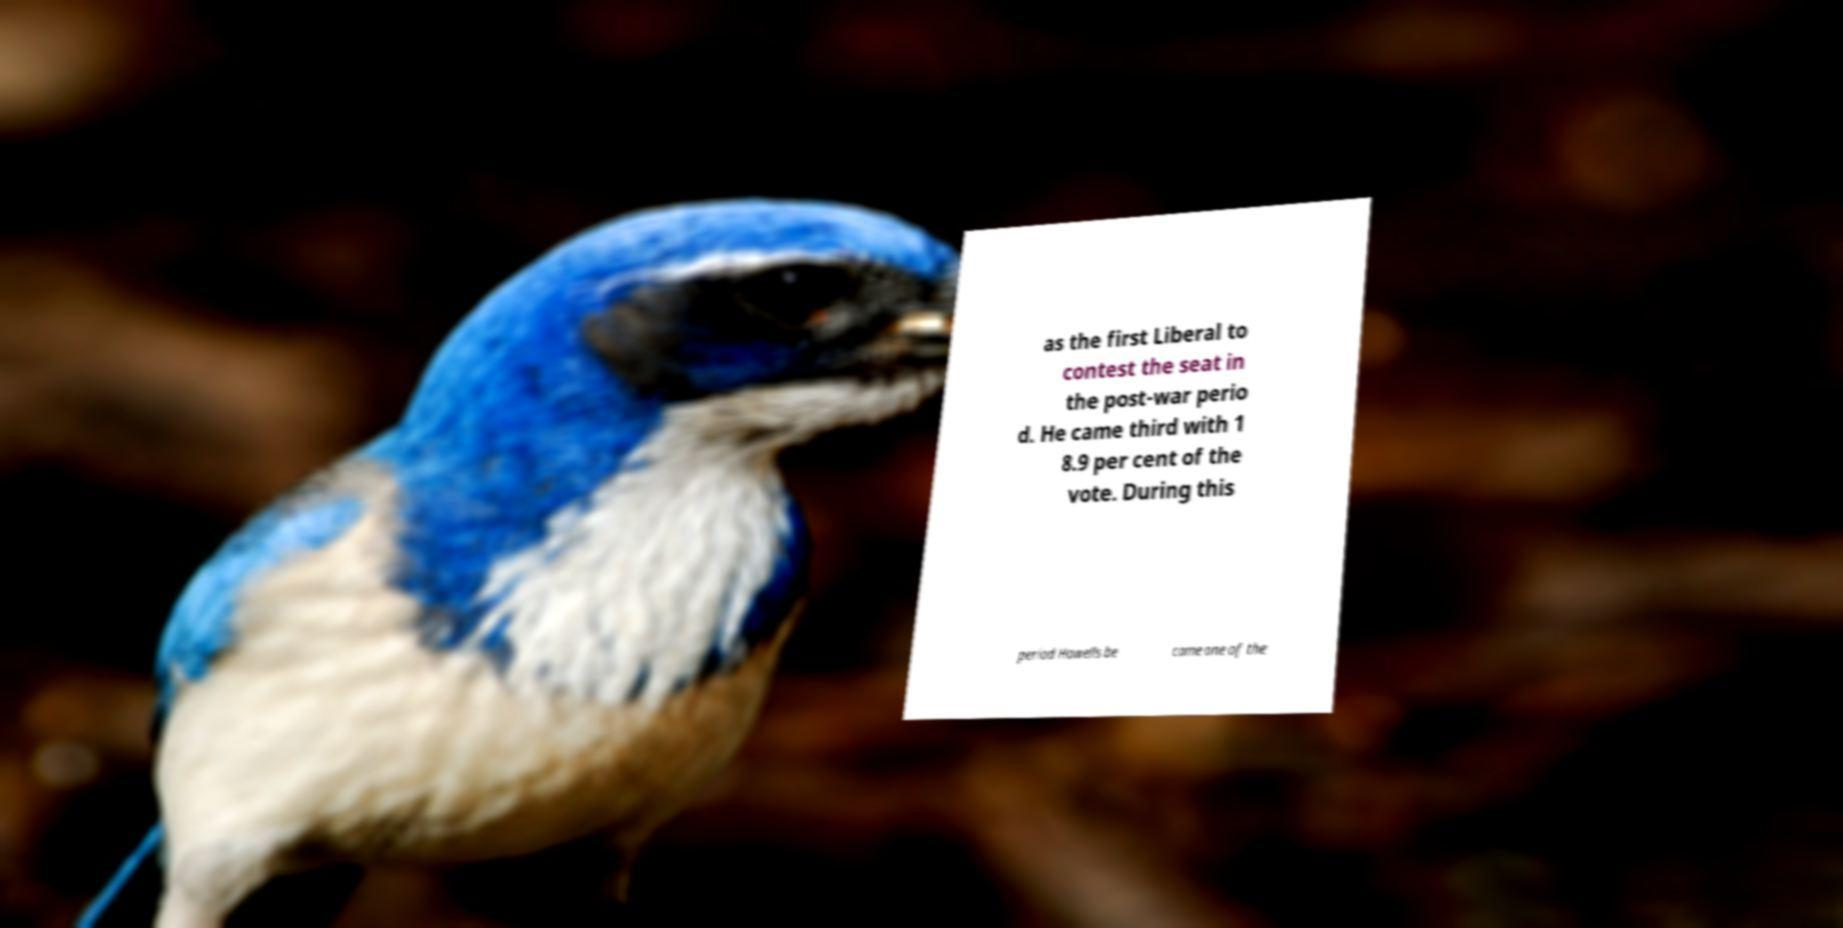Could you extract and type out the text from this image? as the first Liberal to contest the seat in the post-war perio d. He came third with 1 8.9 per cent of the vote. During this period Howells be came one of the 